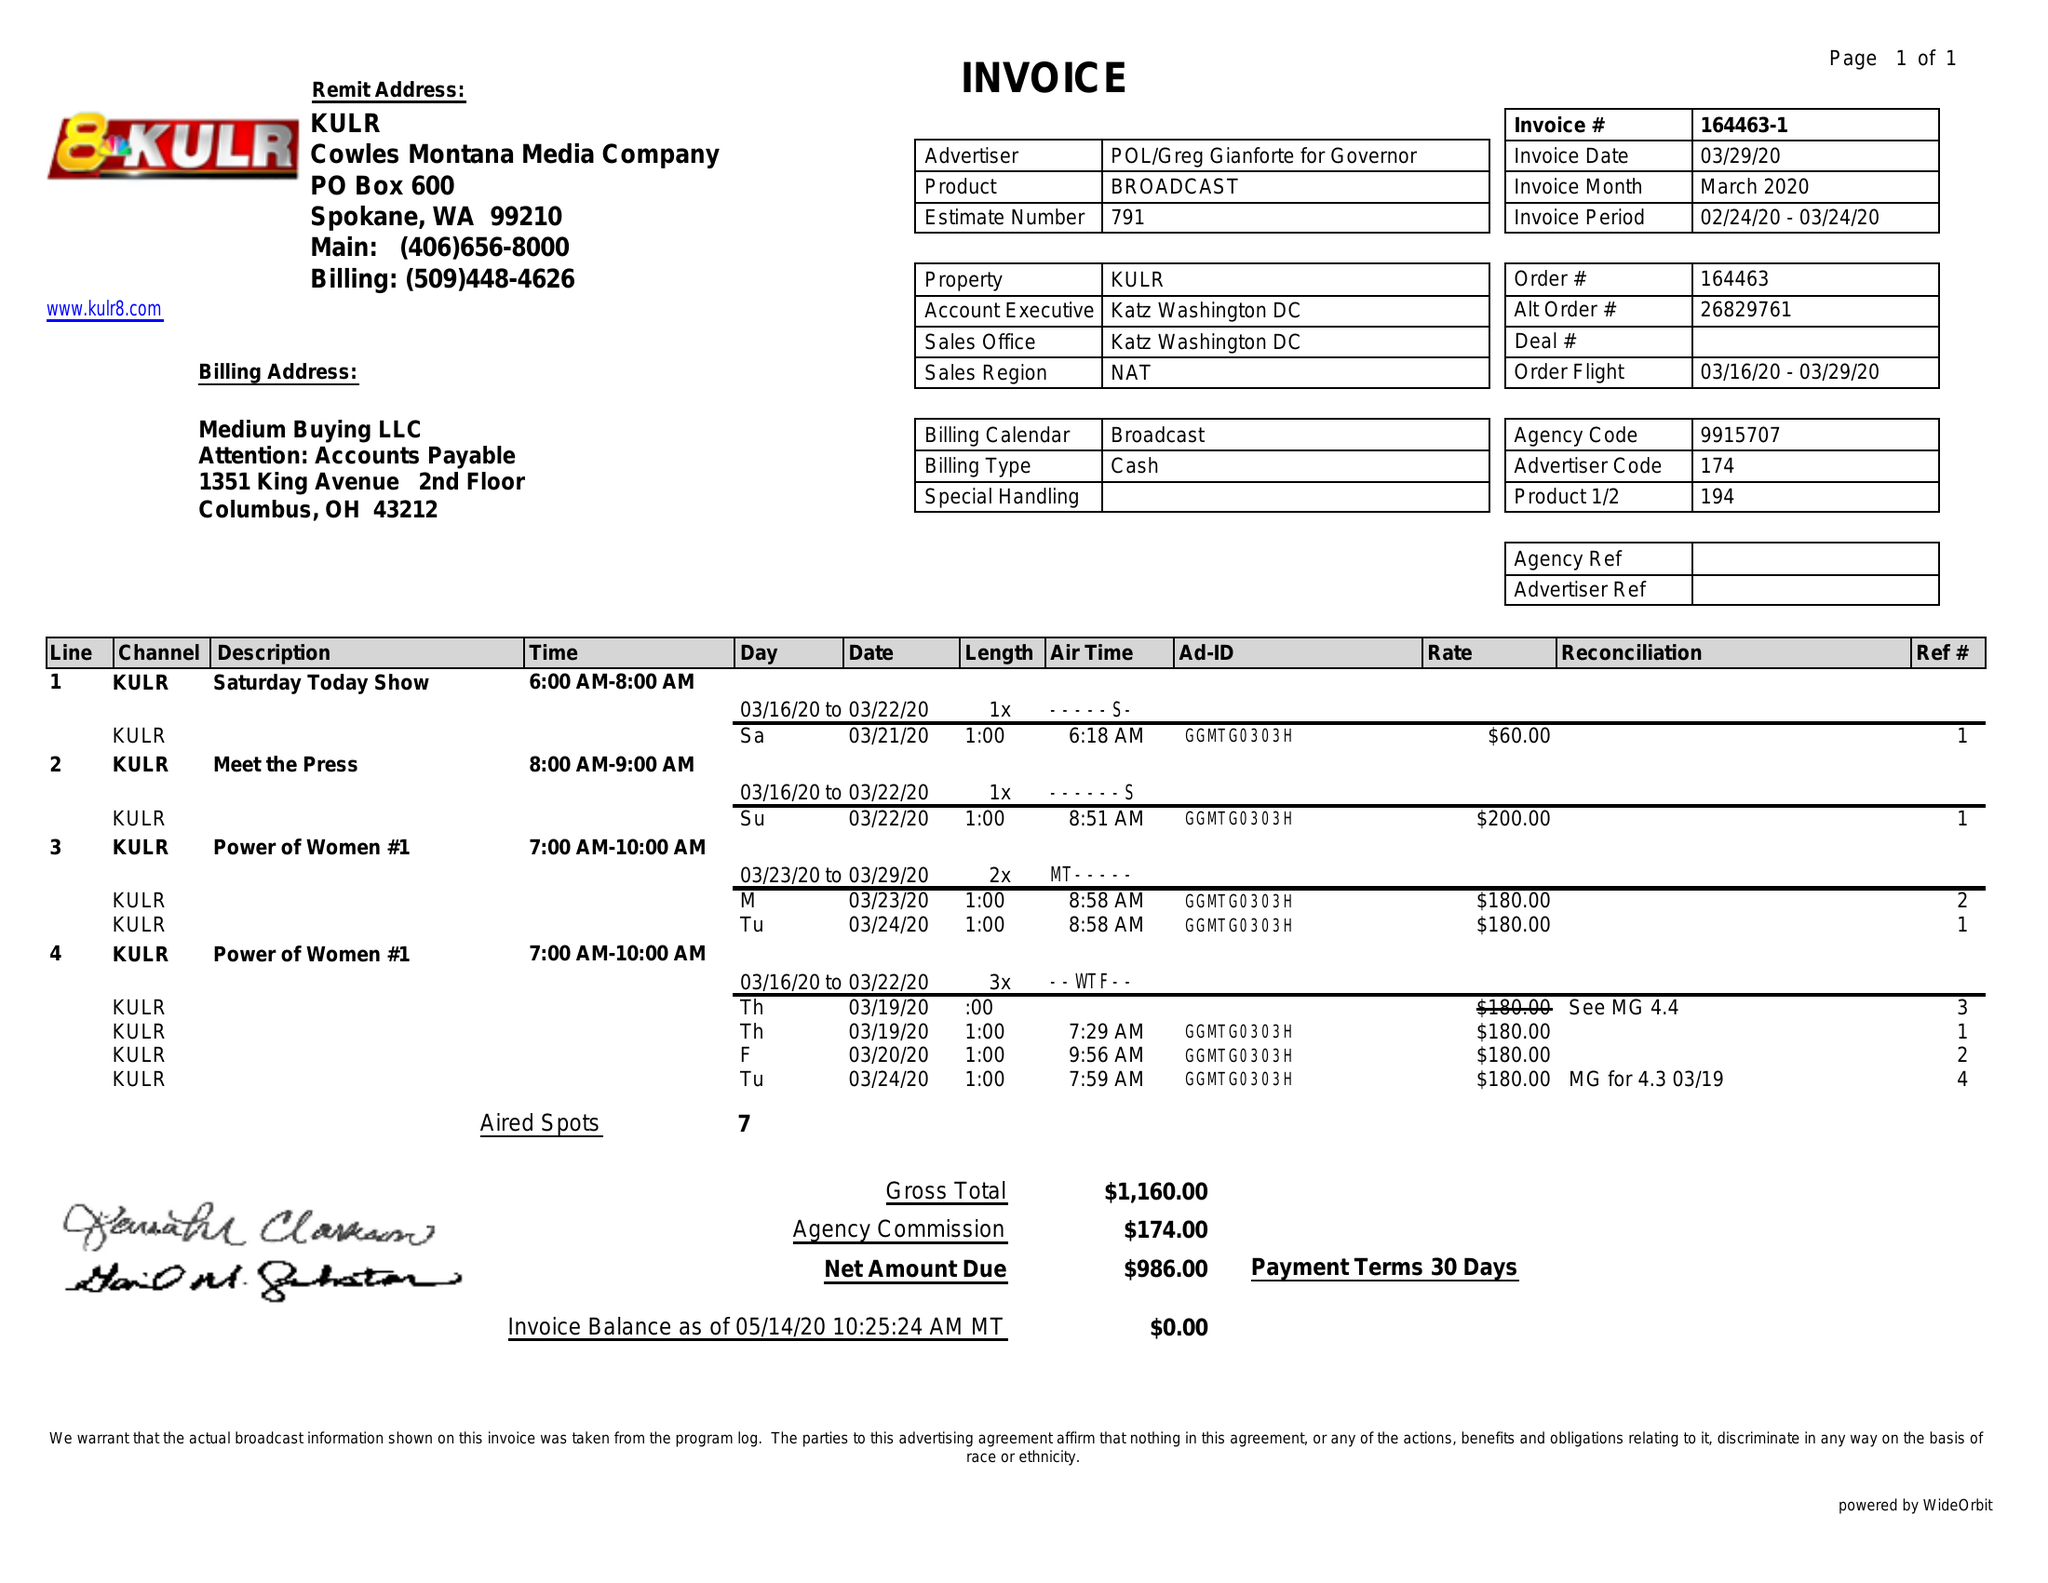What is the value for the flight_from?
Answer the question using a single word or phrase. 02/24/20 